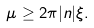<formula> <loc_0><loc_0><loc_500><loc_500>\mu \geq 2 \pi | n | \xi .</formula> 